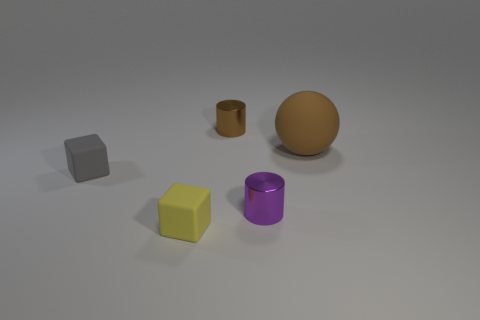Are there an equal number of tiny rubber things and big gray cylinders?
Make the answer very short. No. How many objects are right of the gray rubber thing and left of the brown rubber object?
Offer a very short reply. 3. What material is the cylinder that is in front of the brown object in front of the tiny metal thing behind the big sphere made of?
Your answer should be compact. Metal. What number of big brown things have the same material as the yellow object?
Offer a very short reply. 1. What is the shape of the metal thing that is the same color as the big ball?
Your answer should be compact. Cylinder. There is a brown shiny object that is the same size as the yellow object; what shape is it?
Your answer should be compact. Cylinder. There is a tiny object that is the same color as the big rubber object; what is its material?
Provide a short and direct response. Metal. Are there any brown things on the left side of the tiny gray cube?
Keep it short and to the point. No. Is there a small gray object of the same shape as the large brown rubber thing?
Your response must be concise. No. There is a tiny metallic thing in front of the large brown ball; is its shape the same as the rubber thing right of the small brown metallic cylinder?
Give a very brief answer. No. 